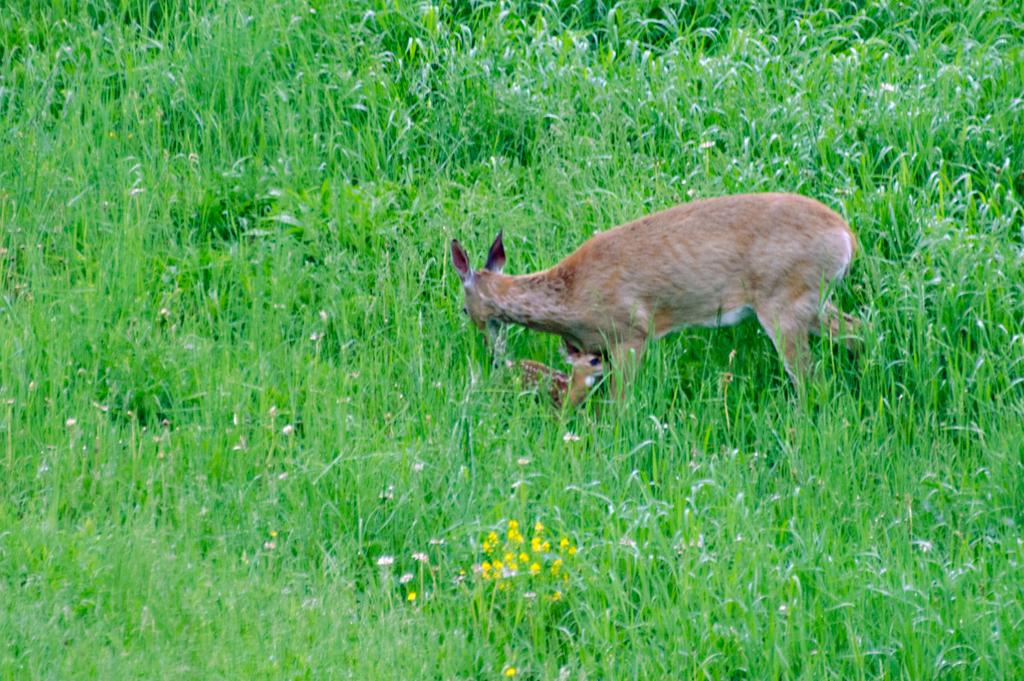What animal can be seen in the image? There is a deer in the image. What is the deer doing in the image? The deer is walking on the ground in the image. What type of vegetation is visible in the image? There is grass visible in the image. What color are the flowers at the bottom of the image? The flowers at the bottom of the image are yellow. Where is the nest of the duck in the image? There is no duck or nest present in the image; it features a deer walking on the ground. 